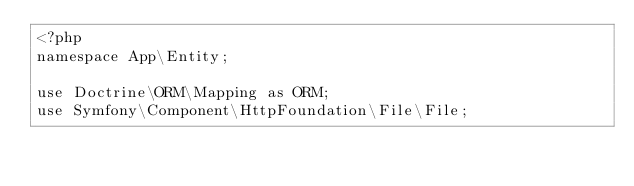Convert code to text. <code><loc_0><loc_0><loc_500><loc_500><_PHP_><?php
namespace App\Entity;

use Doctrine\ORM\Mapping as ORM;
use Symfony\Component\HttpFoundation\File\File;</code> 